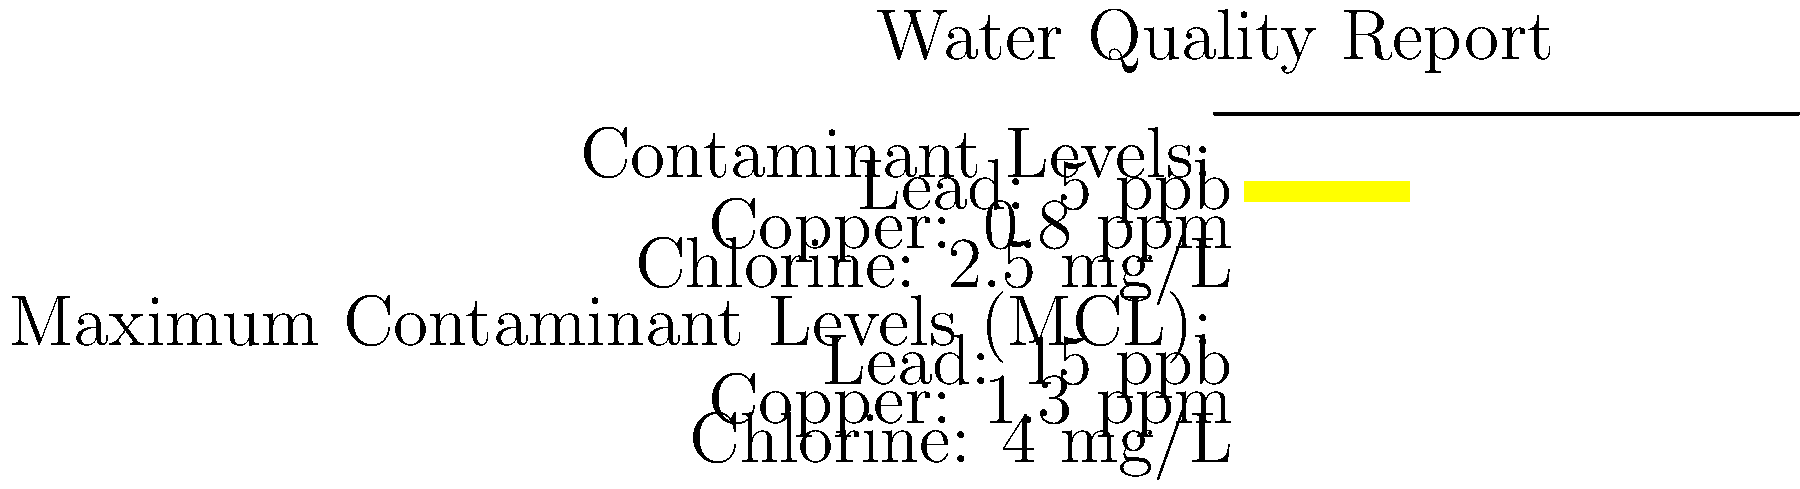Based on the highlighted information in the water quality report, how does the lead level in your tap water compare to the Maximum Contaminant Level (MCL) for lead? To answer this question, we need to follow these steps:

1. Identify the lead level in the tap water from the highlighted section:
   The report shows a lead level of 5 ppb (parts per billion).

2. Locate the Maximum Contaminant Level (MCL) for lead:
   The MCL for lead is listed as 15 ppb.

3. Compare the tap water lead level to the MCL:
   5 ppb (tap water) < 15 ppb (MCL)

4. Interpret the comparison:
   The lead level in the tap water (5 ppb) is below the MCL (15 ppb).

5. Calculate the percentage of the MCL:
   $(5 \text{ ppb} \div 15 \text{ ppb}) \times 100\% = 33.33\%$

Therefore, the lead level in the tap water is approximately one-third of the maximum allowed level, indicating that it is well within the safe range according to regulatory standards.
Answer: The lead level (5 ppb) is 33.33% of the MCL (15 ppb), well below the legal limit. 